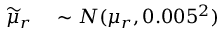<formula> <loc_0><loc_0><loc_500><loc_500>\begin{array} { r l } { \widetilde { \mu } _ { r } } & \sim N ( \mu _ { r } , 0 . 0 0 5 ^ { 2 } ) } \end{array}</formula> 